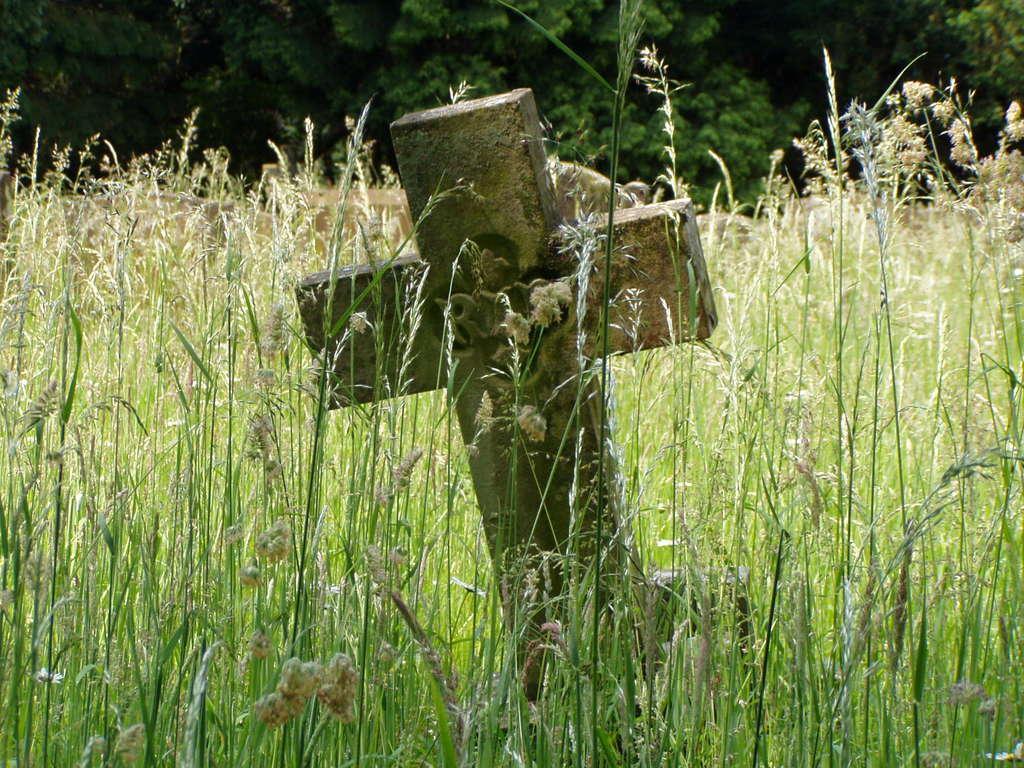Can you describe this image briefly? In this image I can see a plus symbol wall, background I can see plants and trees in green color. 